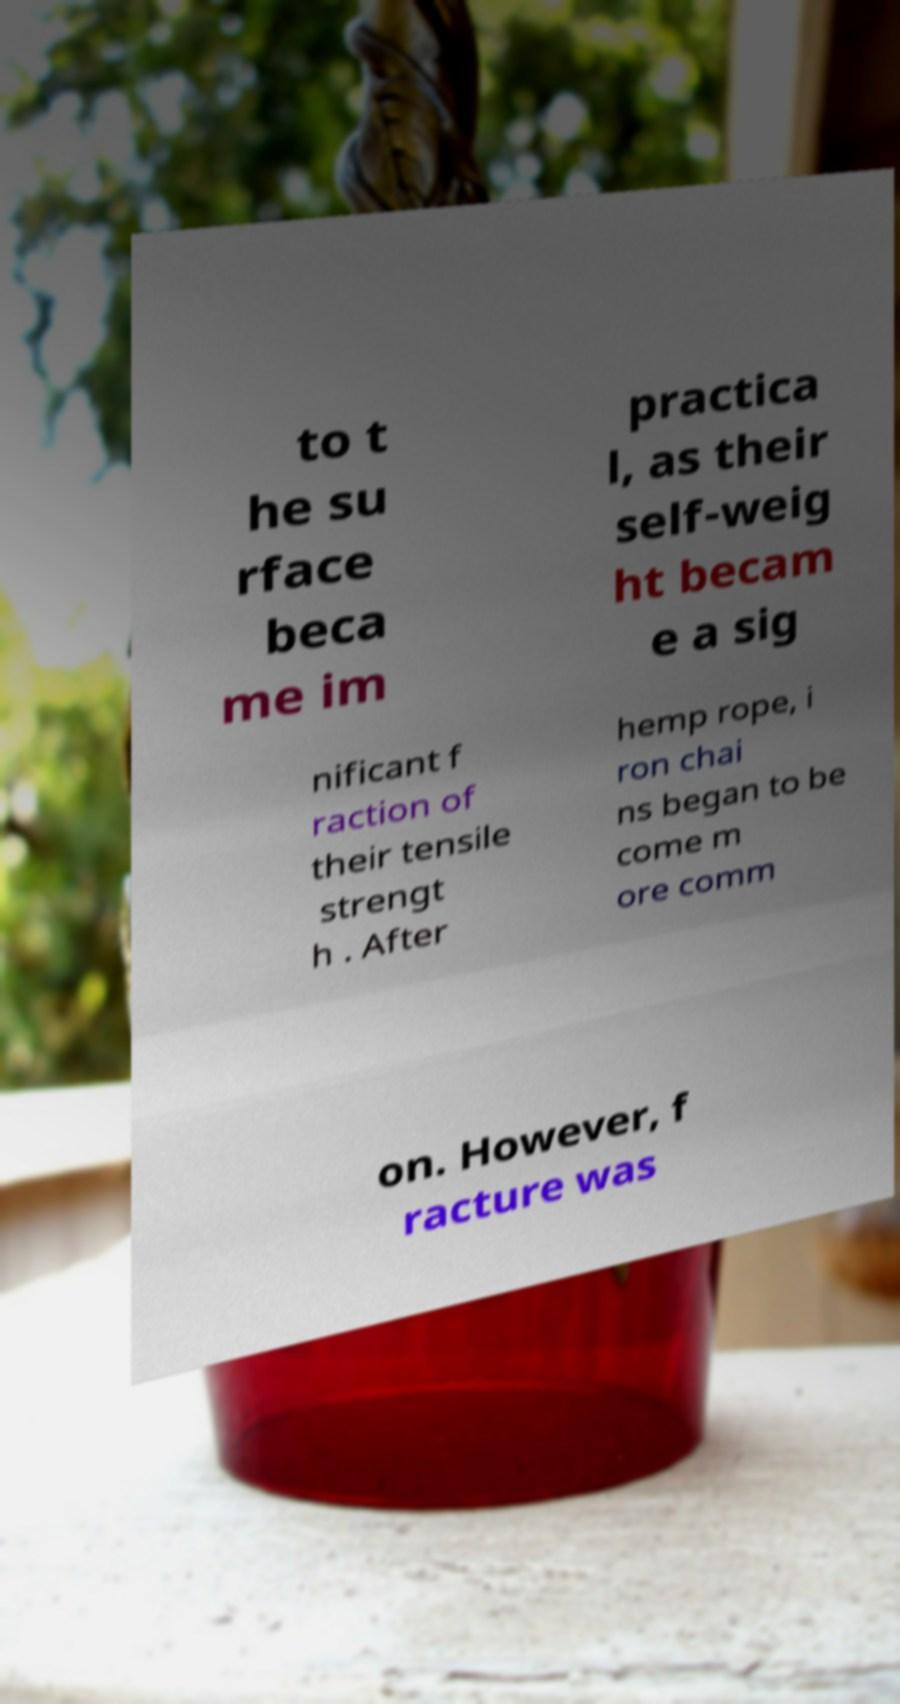For documentation purposes, I need the text within this image transcribed. Could you provide that? to t he su rface beca me im practica l, as their self-weig ht becam e a sig nificant f raction of their tensile strengt h . After hemp rope, i ron chai ns began to be come m ore comm on. However, f racture was 